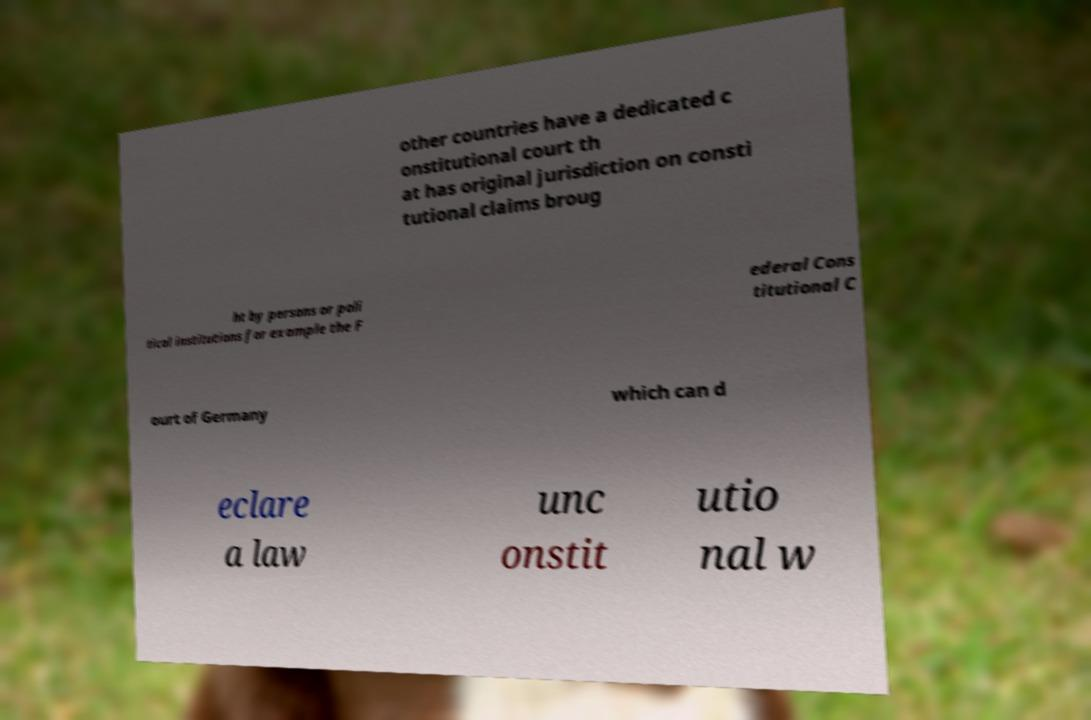Can you read and provide the text displayed in the image?This photo seems to have some interesting text. Can you extract and type it out for me? other countries have a dedicated c onstitutional court th at has original jurisdiction on consti tutional claims broug ht by persons or poli tical institutions for example the F ederal Cons titutional C ourt of Germany which can d eclare a law unc onstit utio nal w 